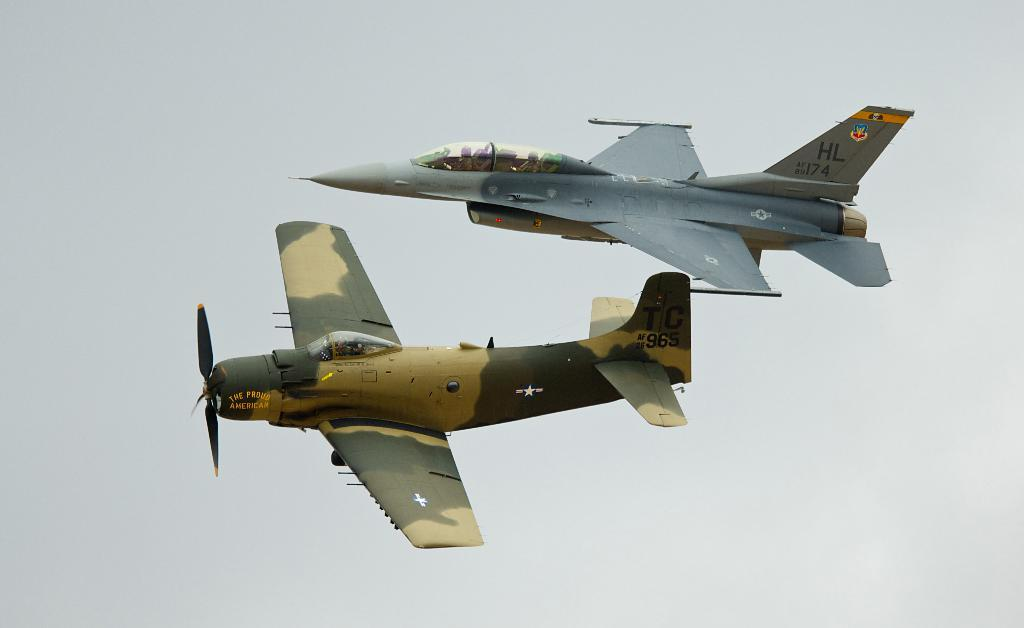<image>
Offer a succinct explanation of the picture presented. Two jets flying in the sky and one jet with HL174 on it's tail. 